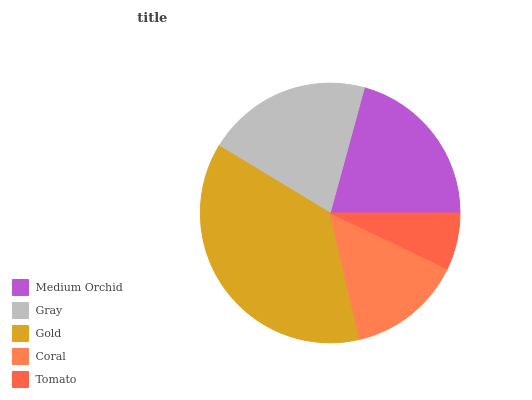Is Tomato the minimum?
Answer yes or no. Yes. Is Gold the maximum?
Answer yes or no. Yes. Is Gray the minimum?
Answer yes or no. No. Is Gray the maximum?
Answer yes or no. No. Is Medium Orchid greater than Gray?
Answer yes or no. Yes. Is Gray less than Medium Orchid?
Answer yes or no. Yes. Is Gray greater than Medium Orchid?
Answer yes or no. No. Is Medium Orchid less than Gray?
Answer yes or no. No. Is Gray the high median?
Answer yes or no. Yes. Is Gray the low median?
Answer yes or no. Yes. Is Medium Orchid the high median?
Answer yes or no. No. Is Gold the low median?
Answer yes or no. No. 